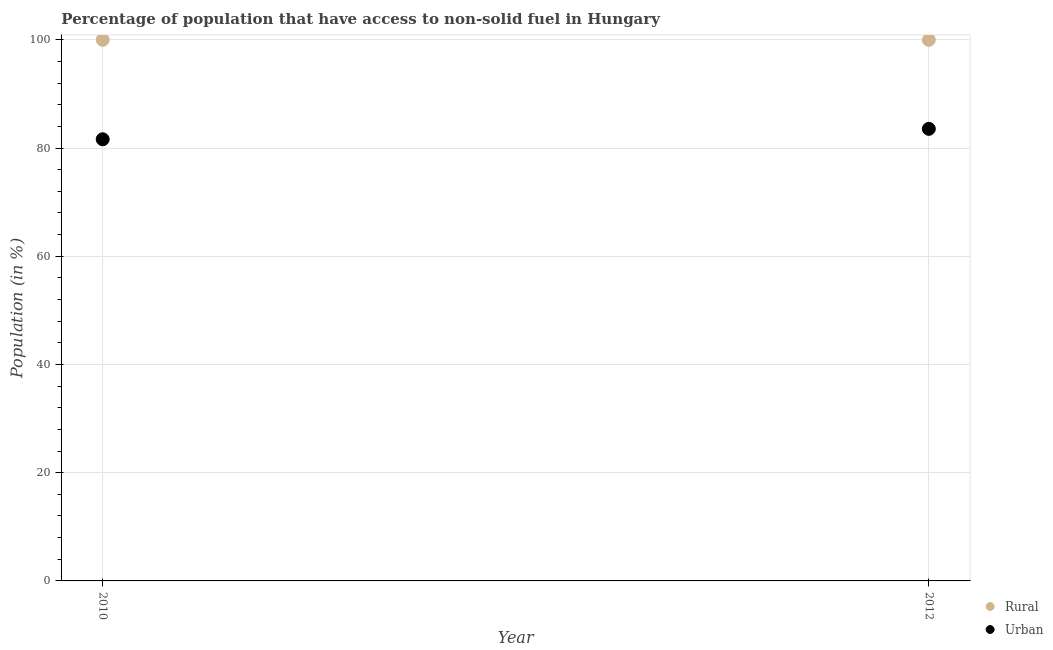What is the rural population in 2012?
Offer a very short reply. 100. Across all years, what is the maximum rural population?
Make the answer very short. 100. Across all years, what is the minimum urban population?
Your answer should be very brief. 81.62. In which year was the urban population maximum?
Make the answer very short. 2012. In which year was the rural population minimum?
Ensure brevity in your answer.  2010. What is the total urban population in the graph?
Keep it short and to the point. 165.18. What is the difference between the urban population in 2010 and the rural population in 2012?
Give a very brief answer. -18.38. In the year 2010, what is the difference between the rural population and urban population?
Provide a short and direct response. 18.38. In how many years, is the rural population greater than 16 %?
Offer a very short reply. 2. What is the ratio of the urban population in 2010 to that in 2012?
Your answer should be compact. 0.98. Is the rural population in 2010 less than that in 2012?
Make the answer very short. No. In how many years, is the urban population greater than the average urban population taken over all years?
Offer a terse response. 1. Is the rural population strictly less than the urban population over the years?
Give a very brief answer. No. How many dotlines are there?
Provide a succinct answer. 2. Are the values on the major ticks of Y-axis written in scientific E-notation?
Your answer should be very brief. No. Does the graph contain any zero values?
Your response must be concise. No. Does the graph contain grids?
Offer a terse response. Yes. What is the title of the graph?
Make the answer very short. Percentage of population that have access to non-solid fuel in Hungary. Does "Male labor force" appear as one of the legend labels in the graph?
Offer a very short reply. No. What is the Population (in %) of Rural in 2010?
Keep it short and to the point. 100. What is the Population (in %) in Urban in 2010?
Ensure brevity in your answer.  81.62. What is the Population (in %) of Urban in 2012?
Make the answer very short. 83.55. Across all years, what is the maximum Population (in %) in Urban?
Provide a short and direct response. 83.55. Across all years, what is the minimum Population (in %) in Rural?
Your answer should be compact. 100. Across all years, what is the minimum Population (in %) of Urban?
Give a very brief answer. 81.62. What is the total Population (in %) of Urban in the graph?
Your answer should be very brief. 165.18. What is the difference between the Population (in %) in Urban in 2010 and that in 2012?
Make the answer very short. -1.93. What is the difference between the Population (in %) of Rural in 2010 and the Population (in %) of Urban in 2012?
Provide a short and direct response. 16.45. What is the average Population (in %) of Urban per year?
Keep it short and to the point. 82.59. In the year 2010, what is the difference between the Population (in %) of Rural and Population (in %) of Urban?
Offer a terse response. 18.38. In the year 2012, what is the difference between the Population (in %) of Rural and Population (in %) of Urban?
Your answer should be very brief. 16.45. What is the ratio of the Population (in %) in Urban in 2010 to that in 2012?
Keep it short and to the point. 0.98. What is the difference between the highest and the second highest Population (in %) of Rural?
Keep it short and to the point. 0. What is the difference between the highest and the second highest Population (in %) in Urban?
Ensure brevity in your answer.  1.93. What is the difference between the highest and the lowest Population (in %) in Rural?
Keep it short and to the point. 0. What is the difference between the highest and the lowest Population (in %) of Urban?
Give a very brief answer. 1.93. 